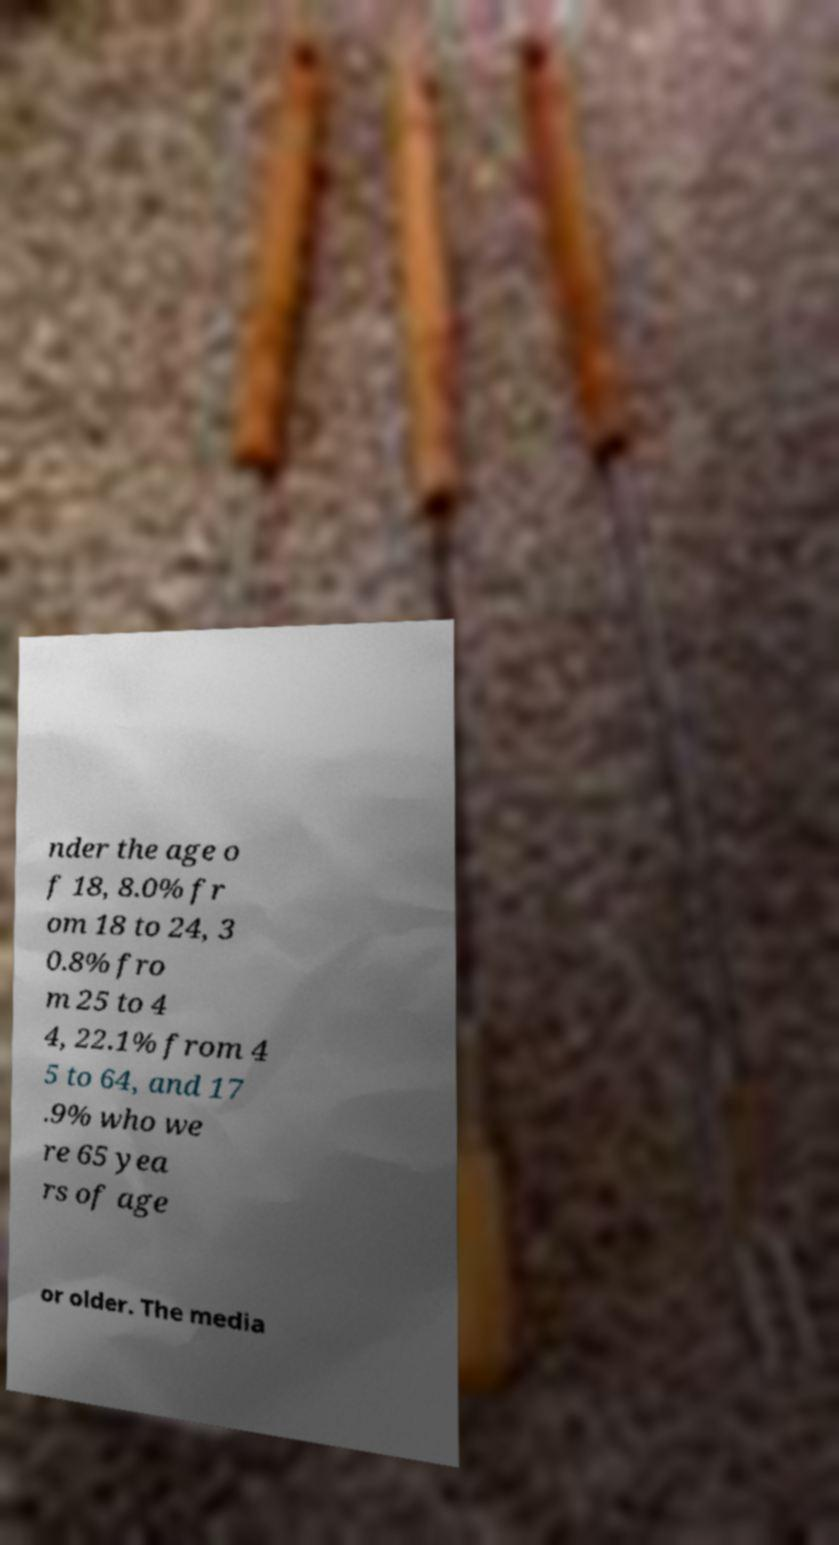Please read and relay the text visible in this image. What does it say? nder the age o f 18, 8.0% fr om 18 to 24, 3 0.8% fro m 25 to 4 4, 22.1% from 4 5 to 64, and 17 .9% who we re 65 yea rs of age or older. The media 